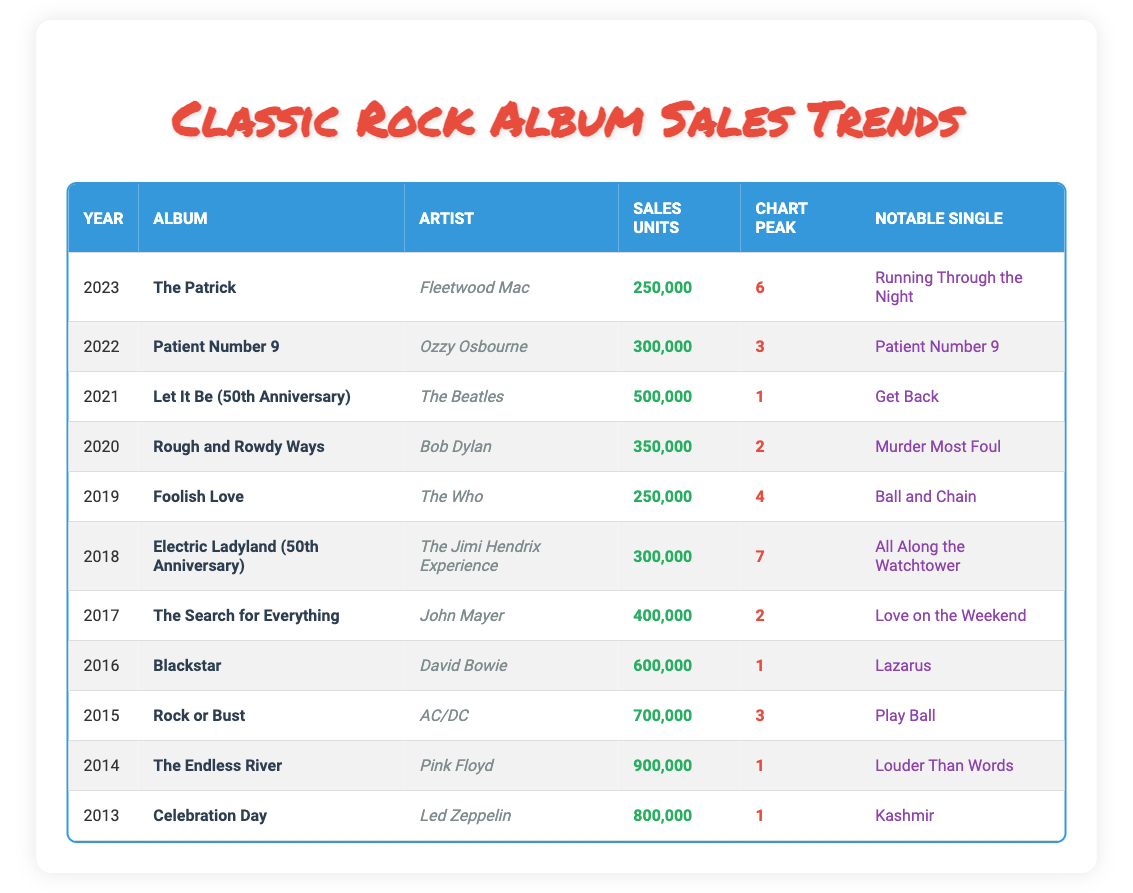What was the highest sales unit recorded for a classic rock album in the last decade? The table shows that the highest sales unit is 900,000 from the album "The Endless River" by Pink Floyd in 2014.
Answer: 900,000 Which artist had an album reach the number one chart peak in 2021? From the table, The Beatles' album "Let It Be (50th Anniversary)" reached the number one chart peak in 2021.
Answer: The Beatles What is the total sales for albums released from 2015 to 2020? Summing the sales units for the albums from 2015 to 2020 gives: 700,000 (2015) + 600,000 (2016) + 400,000 (2017) + 300,000 (2018) + 250,000 (2019) + 350,000 (2020) = 2,600,000.
Answer: 2,600,000 Did any album released in 2022 surpass the sales of the album released in 2019? According to the table, "Patient Number 9" by Ozzy Osbourne in 2022 had sales of 300,000, while "Foolish Love" by The Who in 2019 had sales of 250,000. Thus, the 2022 album surpassed the sales of the 2019 album.
Answer: Yes What was the average sales units of the albums released between 2013 and 2016? The albums from 2013 to 2016 had sales units of 800,000, 900,000, 700,000, and 600,000 respectively. The average is calculated as (800,000 + 900,000 + 700,000 + 600,000) / 4 = 775,000.
Answer: 775,000 Which artist has the most recent album listed in the table? The table lists "The Patrick" by Fleetwood Mac released in 2023 as the most recent album.
Answer: Fleetwood Mac How many albums had sales of less than 400,000 units? The table lists three albums with sales of less than 400,000 units: "The Search for Everything" (400,000), "Electric Ladyland (50th Anniversary)" (300,000), and "Foolish Love" (250,000) totaling to three albums.
Answer: Three What was the notable single for the album "Blackstar"? The table specifies "Lazarus" as the notable single for David Bowie's album "Blackstar" released in 2016.
Answer: Lazarus Which year saw the lowest album sales and what were the sales units? "Foolish Love" by The Who in 2019 recorded the lowest sales in the last decade at 250,000 units.
Answer: 2019, 250,000 